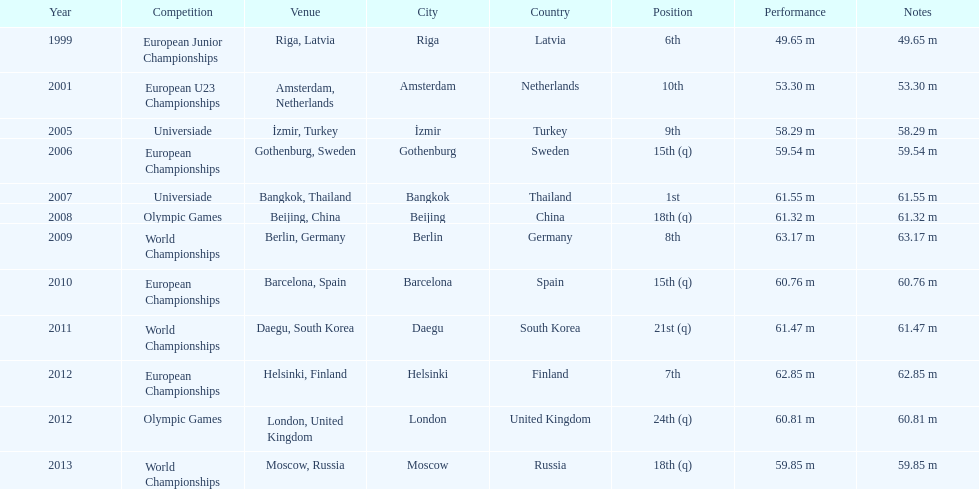Before 2007, what was the top position attained? 6th. 